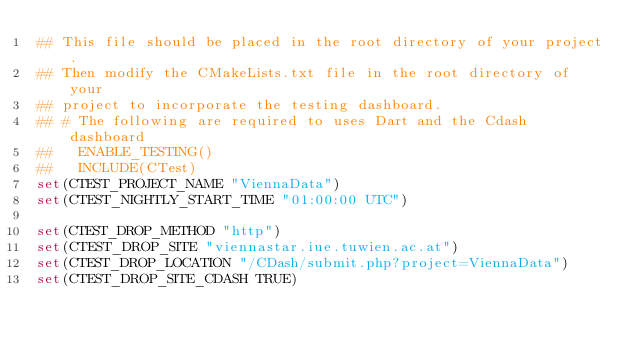<code> <loc_0><loc_0><loc_500><loc_500><_CMake_>## This file should be placed in the root directory of your project.
## Then modify the CMakeLists.txt file in the root directory of your
## project to incorporate the testing dashboard.
## # The following are required to uses Dart and the Cdash dashboard
##   ENABLE_TESTING()
##   INCLUDE(CTest)
set(CTEST_PROJECT_NAME "ViennaData")
set(CTEST_NIGHTLY_START_TIME "01:00:00 UTC")

set(CTEST_DROP_METHOD "http")
set(CTEST_DROP_SITE "viennastar.iue.tuwien.ac.at")
set(CTEST_DROP_LOCATION "/CDash/submit.php?project=ViennaData")
set(CTEST_DROP_SITE_CDASH TRUE)
</code> 